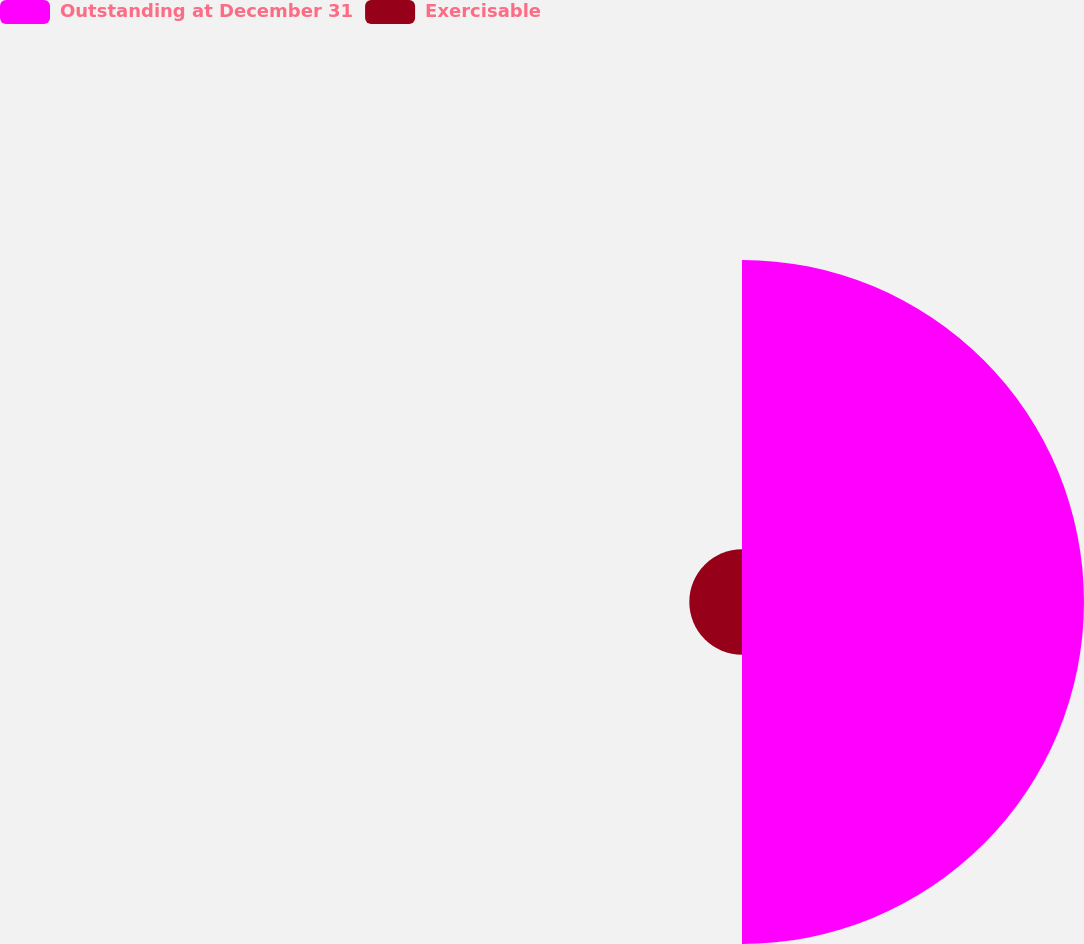<chart> <loc_0><loc_0><loc_500><loc_500><pie_chart><fcel>Outstanding at December 31<fcel>Exercisable<nl><fcel>86.65%<fcel>13.35%<nl></chart> 